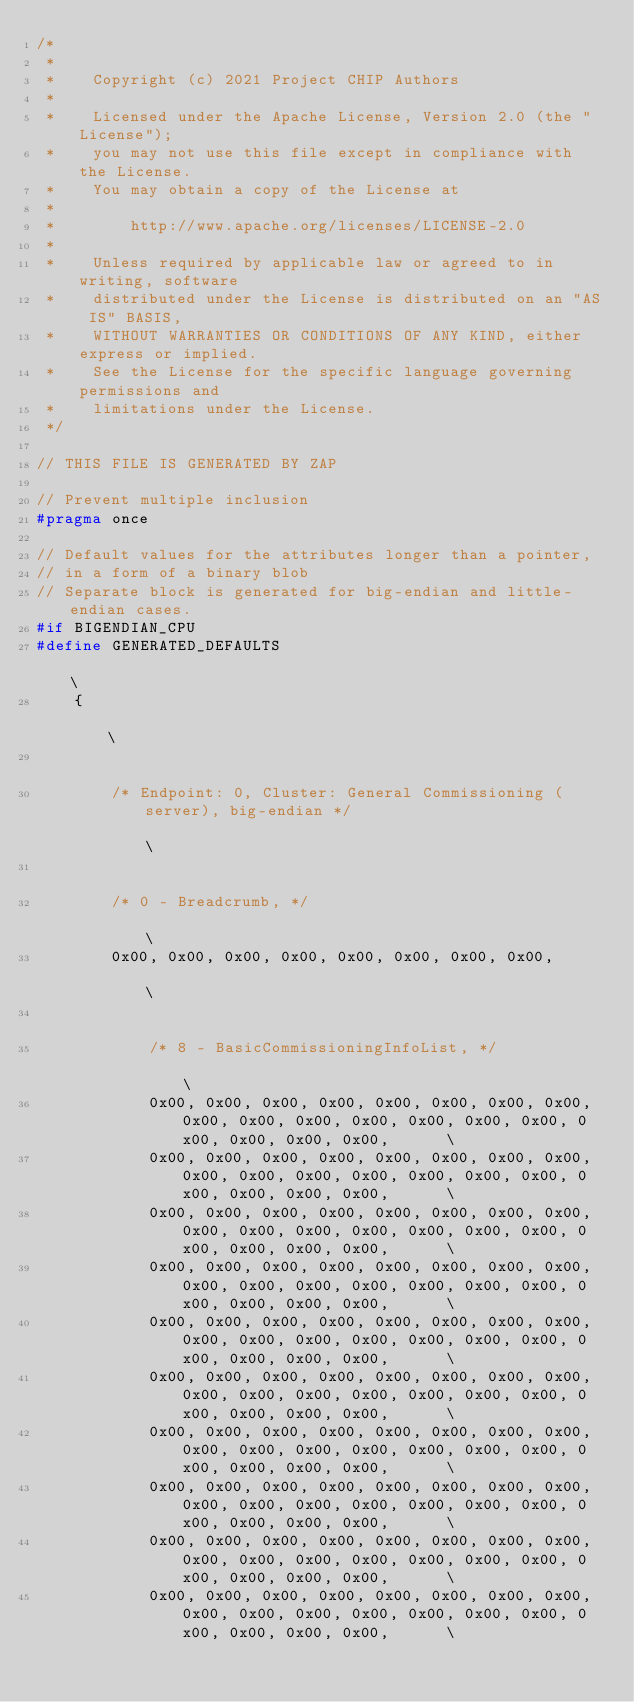Convert code to text. <code><loc_0><loc_0><loc_500><loc_500><_C_>/*
 *
 *    Copyright (c) 2021 Project CHIP Authors
 *
 *    Licensed under the Apache License, Version 2.0 (the "License");
 *    you may not use this file except in compliance with the License.
 *    You may obtain a copy of the License at
 *
 *        http://www.apache.org/licenses/LICENSE-2.0
 *
 *    Unless required by applicable law or agreed to in writing, software
 *    distributed under the License is distributed on an "AS IS" BASIS,
 *    WITHOUT WARRANTIES OR CONDITIONS OF ANY KIND, either express or implied.
 *    See the License for the specific language governing permissions and
 *    limitations under the License.
 */

// THIS FILE IS GENERATED BY ZAP

// Prevent multiple inclusion
#pragma once

// Default values for the attributes longer than a pointer,
// in a form of a binary blob
// Separate block is generated for big-endian and little-endian cases.
#if BIGENDIAN_CPU
#define GENERATED_DEFAULTS                                                                                                         \
    {                                                                                                                              \
                                                                                                                                   \
        /* Endpoint: 0, Cluster: General Commissioning (server), big-endian */                                                     \
                                                                                                                                   \
        /* 0 - Breadcrumb, */                                                                                                      \
        0x00, 0x00, 0x00, 0x00, 0x00, 0x00, 0x00, 0x00,                                                                            \
                                                                                                                                   \
            /* 8 - BasicCommissioningInfoList, */                                                                                  \
            0x00, 0x00, 0x00, 0x00, 0x00, 0x00, 0x00, 0x00, 0x00, 0x00, 0x00, 0x00, 0x00, 0x00, 0x00, 0x00, 0x00, 0x00, 0x00,      \
            0x00, 0x00, 0x00, 0x00, 0x00, 0x00, 0x00, 0x00, 0x00, 0x00, 0x00, 0x00, 0x00, 0x00, 0x00, 0x00, 0x00, 0x00, 0x00,      \
            0x00, 0x00, 0x00, 0x00, 0x00, 0x00, 0x00, 0x00, 0x00, 0x00, 0x00, 0x00, 0x00, 0x00, 0x00, 0x00, 0x00, 0x00, 0x00,      \
            0x00, 0x00, 0x00, 0x00, 0x00, 0x00, 0x00, 0x00, 0x00, 0x00, 0x00, 0x00, 0x00, 0x00, 0x00, 0x00, 0x00, 0x00, 0x00,      \
            0x00, 0x00, 0x00, 0x00, 0x00, 0x00, 0x00, 0x00, 0x00, 0x00, 0x00, 0x00, 0x00, 0x00, 0x00, 0x00, 0x00, 0x00, 0x00,      \
            0x00, 0x00, 0x00, 0x00, 0x00, 0x00, 0x00, 0x00, 0x00, 0x00, 0x00, 0x00, 0x00, 0x00, 0x00, 0x00, 0x00, 0x00, 0x00,      \
            0x00, 0x00, 0x00, 0x00, 0x00, 0x00, 0x00, 0x00, 0x00, 0x00, 0x00, 0x00, 0x00, 0x00, 0x00, 0x00, 0x00, 0x00, 0x00,      \
            0x00, 0x00, 0x00, 0x00, 0x00, 0x00, 0x00, 0x00, 0x00, 0x00, 0x00, 0x00, 0x00, 0x00, 0x00, 0x00, 0x00, 0x00, 0x00,      \
            0x00, 0x00, 0x00, 0x00, 0x00, 0x00, 0x00, 0x00, 0x00, 0x00, 0x00, 0x00, 0x00, 0x00, 0x00, 0x00, 0x00, 0x00, 0x00,      \
            0x00, 0x00, 0x00, 0x00, 0x00, 0x00, 0x00, 0x00, 0x00, 0x00, 0x00, 0x00, 0x00, 0x00, 0x00, 0x00, 0x00, 0x00, 0x00,      \</code> 